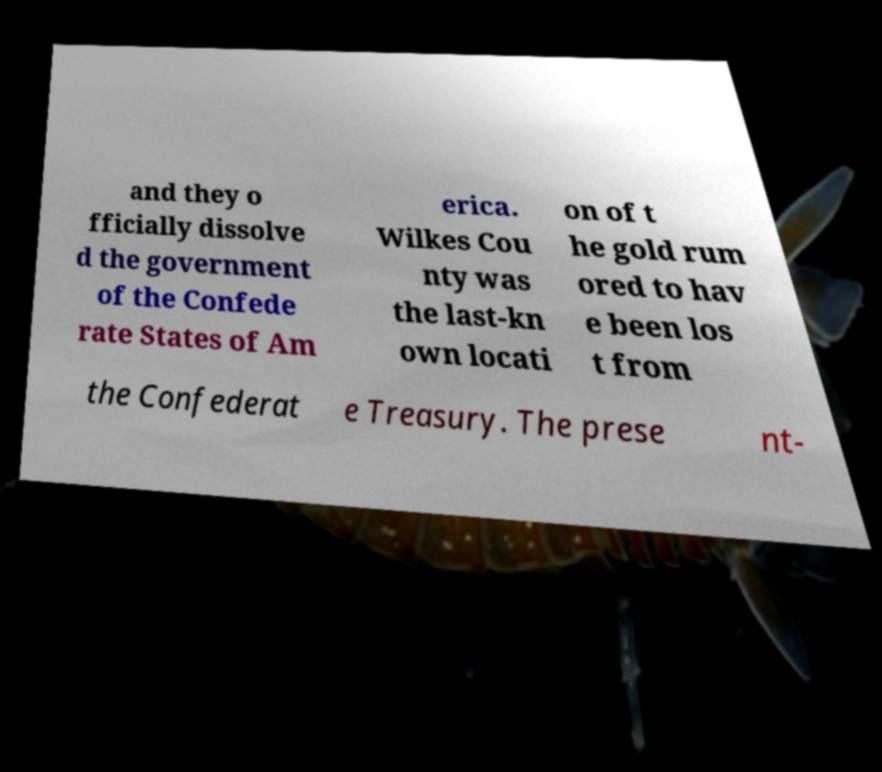I need the written content from this picture converted into text. Can you do that? and they o fficially dissolve d the government of the Confede rate States of Am erica. Wilkes Cou nty was the last-kn own locati on of t he gold rum ored to hav e been los t from the Confederat e Treasury. The prese nt- 